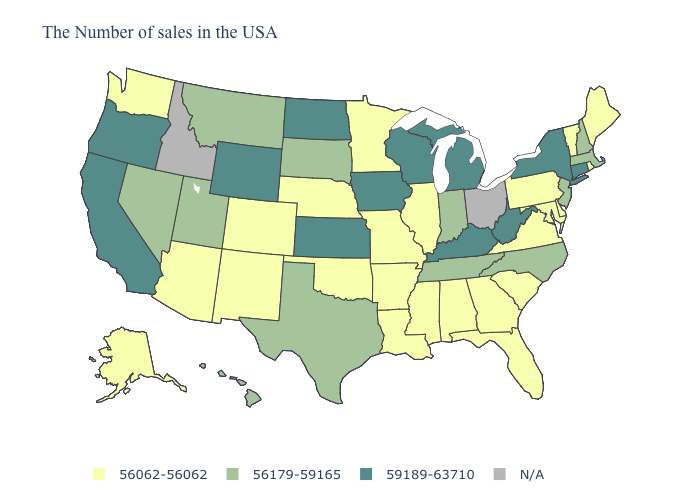How many symbols are there in the legend?
Answer briefly. 4. Name the states that have a value in the range 56179-59165?
Give a very brief answer. Massachusetts, New Hampshire, New Jersey, North Carolina, Indiana, Tennessee, Texas, South Dakota, Utah, Montana, Nevada, Hawaii. Which states have the lowest value in the USA?
Keep it brief. Maine, Rhode Island, Vermont, Delaware, Maryland, Pennsylvania, Virginia, South Carolina, Florida, Georgia, Alabama, Illinois, Mississippi, Louisiana, Missouri, Arkansas, Minnesota, Nebraska, Oklahoma, Colorado, New Mexico, Arizona, Washington, Alaska. Among the states that border Alabama , does Tennessee have the highest value?
Write a very short answer. Yes. Name the states that have a value in the range N/A?
Concise answer only. Ohio, Idaho. What is the highest value in the MidWest ?
Keep it brief. 59189-63710. What is the lowest value in states that border North Carolina?
Keep it brief. 56062-56062. What is the value of Ohio?
Give a very brief answer. N/A. Name the states that have a value in the range 56062-56062?
Concise answer only. Maine, Rhode Island, Vermont, Delaware, Maryland, Pennsylvania, Virginia, South Carolina, Florida, Georgia, Alabama, Illinois, Mississippi, Louisiana, Missouri, Arkansas, Minnesota, Nebraska, Oklahoma, Colorado, New Mexico, Arizona, Washington, Alaska. Does New York have the highest value in the Northeast?
Quick response, please. Yes. Does the map have missing data?
Write a very short answer. Yes. Name the states that have a value in the range N/A?
Answer briefly. Ohio, Idaho. Among the states that border Oregon , does Washington have the lowest value?
Answer briefly. Yes. What is the lowest value in the USA?
Keep it brief. 56062-56062. 